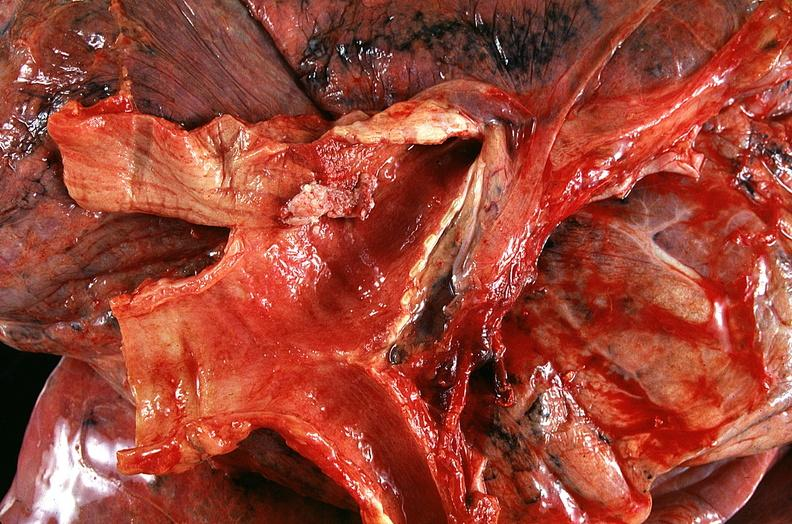what does this image show?
Answer the question using a single word or phrase. Lung 